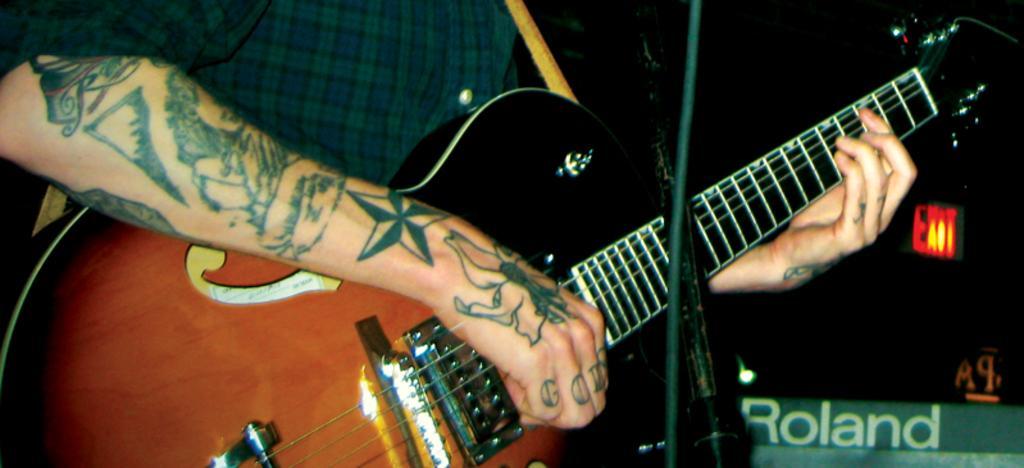Can you describe this image briefly? This is a man standing and playing guitar. This is a tattoo on the hand. This looks like a mike stand. 